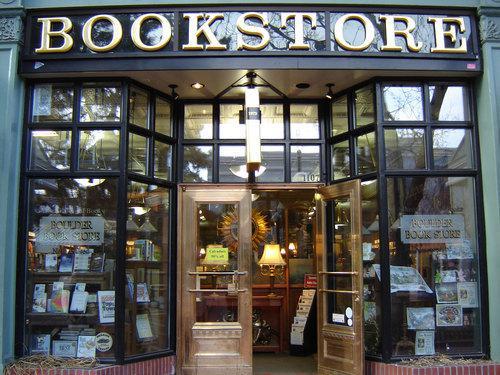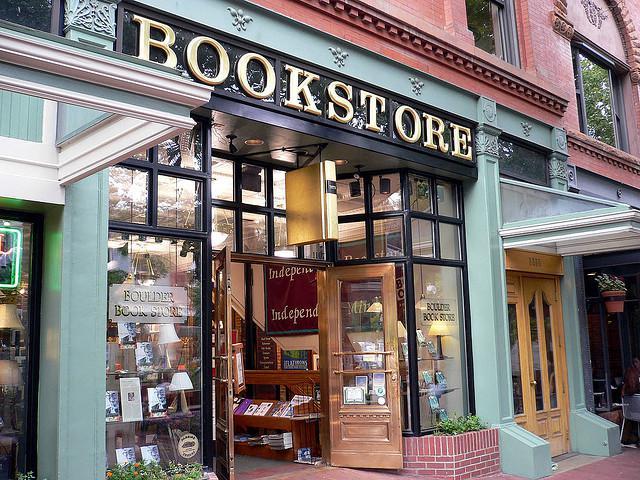The first image is the image on the left, the second image is the image on the right. Evaluate the accuracy of this statement regarding the images: "At least one image is inside the store, and there is a window you can see out of.". Is it true? Answer yes or no. No. 